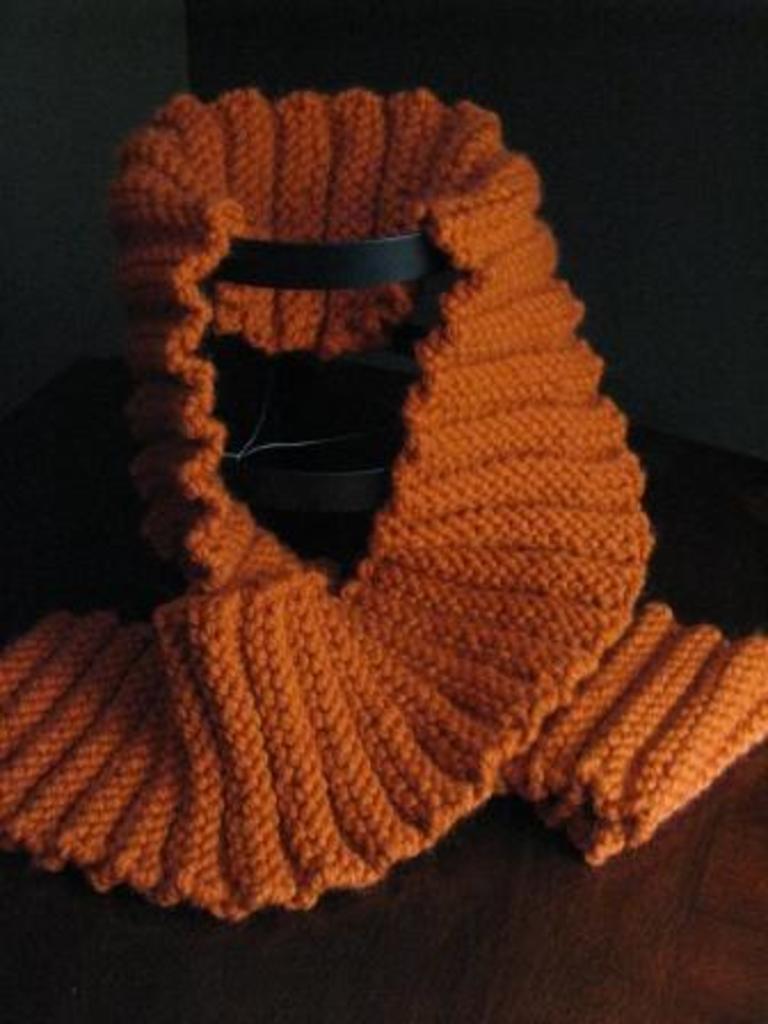Could you give a brief overview of what you see in this image? In this image we can see a woolen scarf which is in orange color is kept on a black stand. 